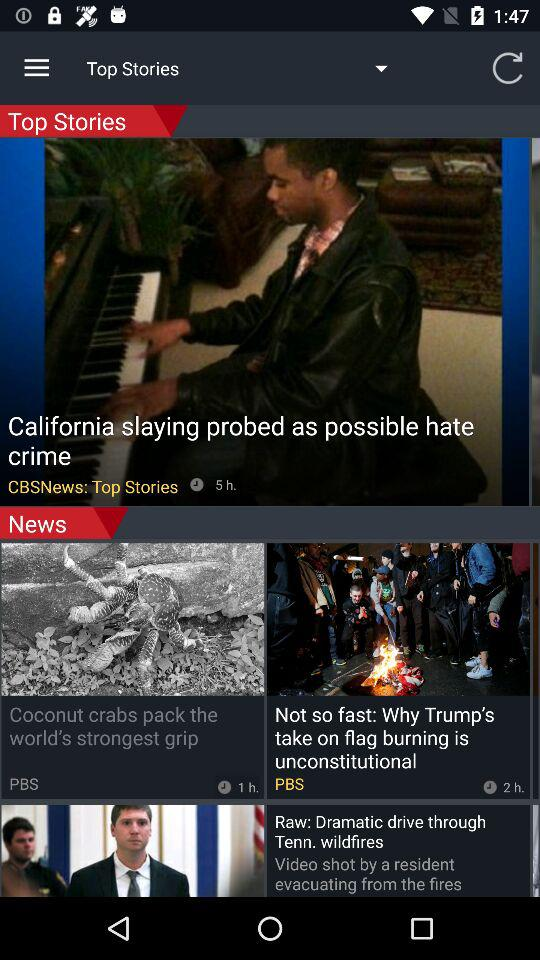How many hours ago did "CBSNews" air? "CBSNews" was aired 5 hours ago. 